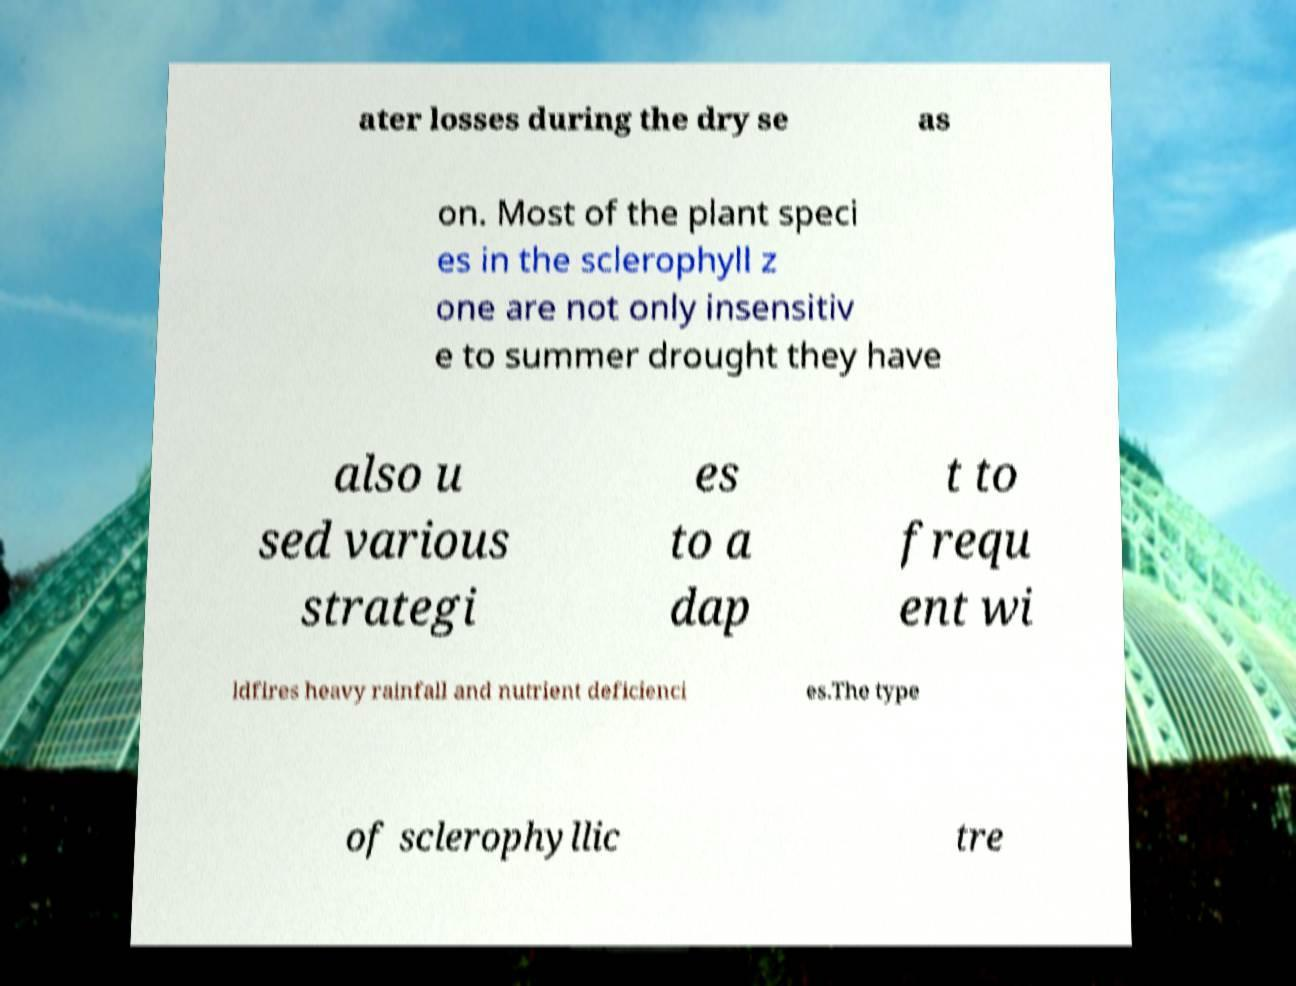There's text embedded in this image that I need extracted. Can you transcribe it verbatim? ater losses during the dry se as on. Most of the plant speci es in the sclerophyll z one are not only insensitiv e to summer drought they have also u sed various strategi es to a dap t to frequ ent wi ldfires heavy rainfall and nutrient deficienci es.The type of sclerophyllic tre 